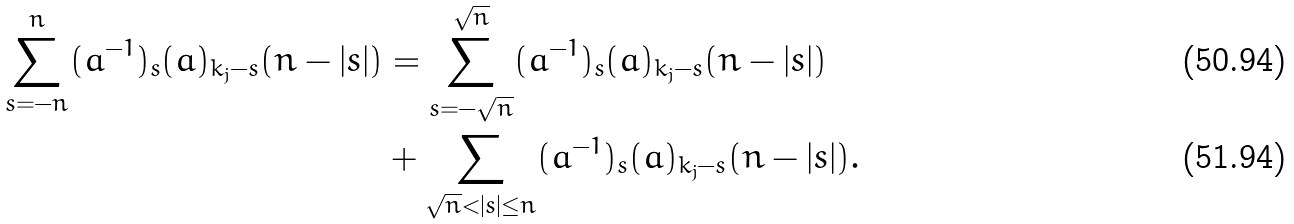<formula> <loc_0><loc_0><loc_500><loc_500>\sum _ { s = - n } ^ { n } ( { a ^ { - 1 } } ) _ { s } ( { a } ) _ { k _ { j } - s } ( n - | s | ) & = \sum _ { s = - \sqrt { n } } ^ { \sqrt { n } } ( { a ^ { - 1 } } ) _ { s } ( { a } ) _ { k _ { j } - s } ( n - | s | ) \\ & + \sum _ { \sqrt { n } < | s | \leq n } ( { a ^ { - 1 } } ) _ { s } ( { a } ) _ { k _ { j } - s } ( n - | s | ) .</formula> 